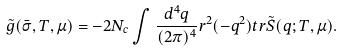Convert formula to latex. <formula><loc_0><loc_0><loc_500><loc_500>\tilde { g } ( \bar { \sigma } , T , \mu ) = - 2 N _ { c } \int \frac { d ^ { 4 } q } { ( 2 \pi ) ^ { 4 } } r ^ { 2 } ( - q ^ { 2 } ) t r \tilde { S } ( q ; T , \mu ) .</formula> 